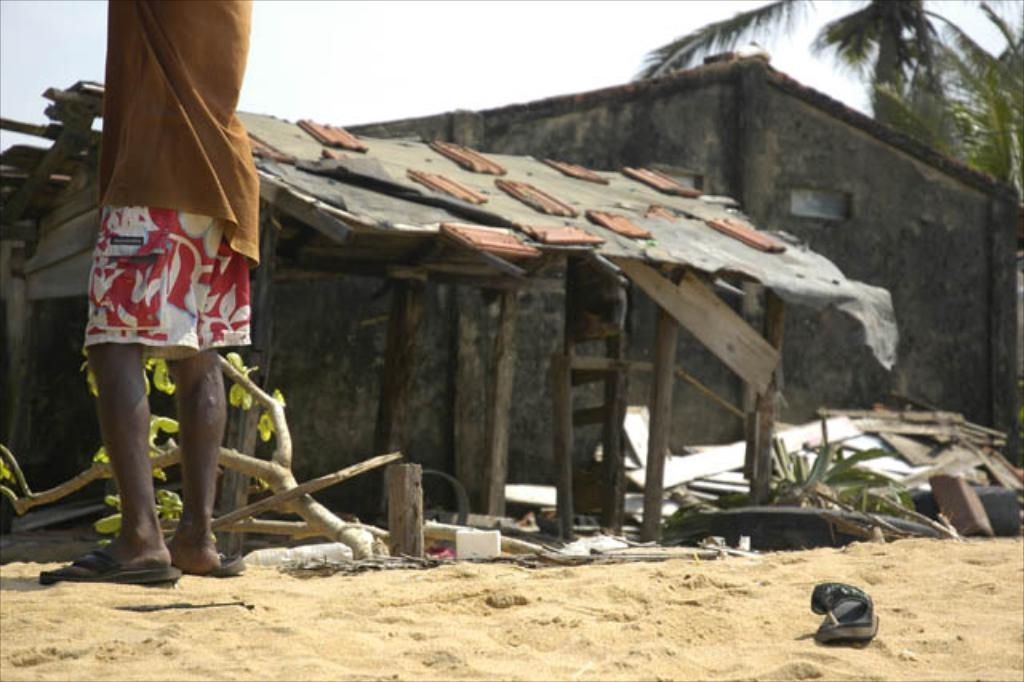Who or what is present in the image? There is a person in the image. What type of structure can be seen in the image? There is a wooden house in the image. What kind of terrain is visible in the image? There is sand visible in the image. What type of footwear is present at the bottom of the image? There is a slipper at the bottom of the image. What type of mine is visible in the image? There is no mine present in the image. What achievements has the person in the image accomplished? The image does not provide information about the person's achievements, so it cannot be determined from the image. 